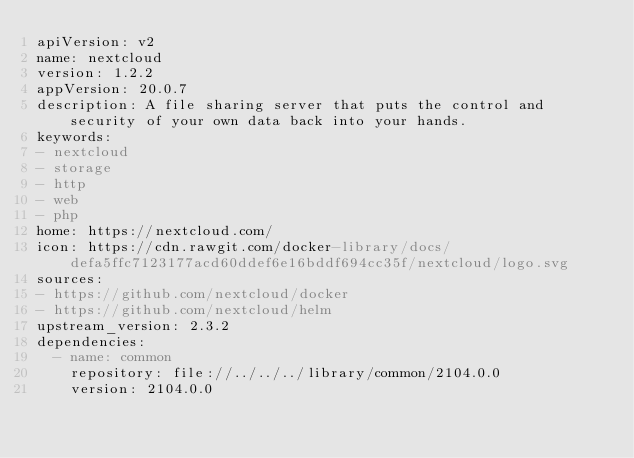<code> <loc_0><loc_0><loc_500><loc_500><_YAML_>apiVersion: v2
name: nextcloud
version: 1.2.2
appVersion: 20.0.7
description: A file sharing server that puts the control and security of your own data back into your hands.
keywords:
- nextcloud
- storage
- http
- web
- php
home: https://nextcloud.com/
icon: https://cdn.rawgit.com/docker-library/docs/defa5ffc7123177acd60ddef6e16bddf694cc35f/nextcloud/logo.svg
sources:
- https://github.com/nextcloud/docker
- https://github.com/nextcloud/helm
upstream_version: 2.3.2
dependencies:
  - name: common
    repository: file://../../../library/common/2104.0.0
    version: 2104.0.0

</code> 